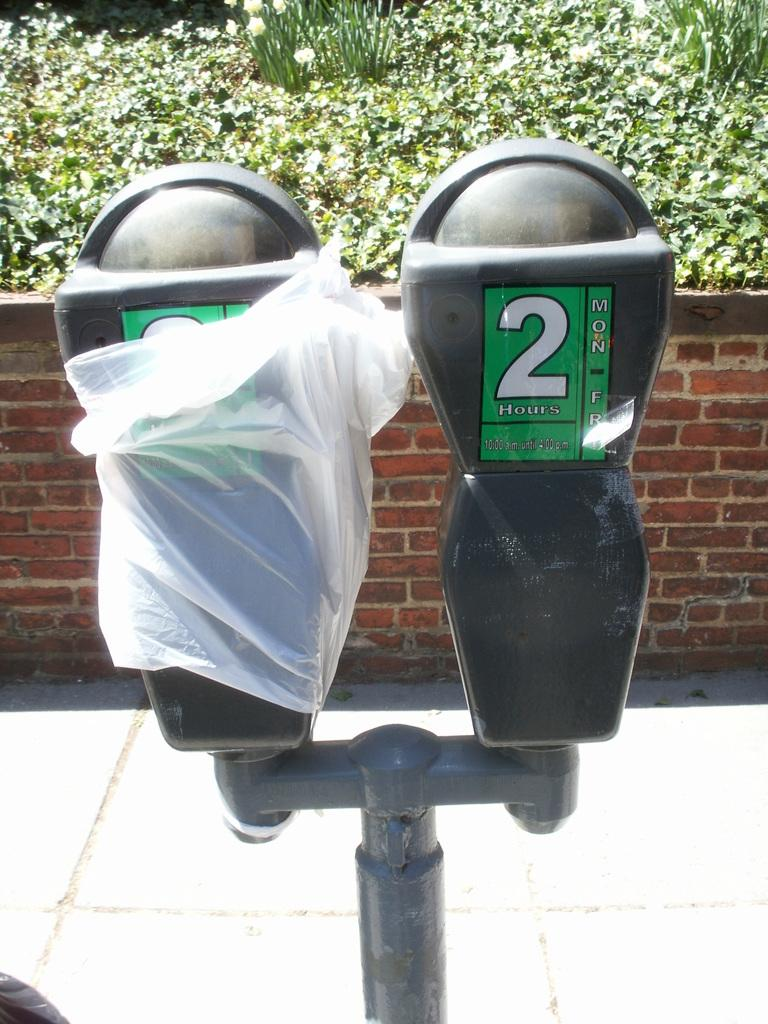<image>
Offer a succinct explanation of the picture presented. The parking meter indicates that parking is available Monday through Friday from 10 AM until 4 PM. 